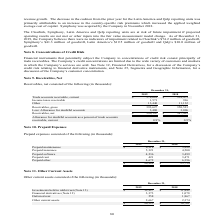According to Sykes Enterprises Incorporated's financial document, What was the amount of deferred rent in 2019? According to the financial document, 558 (in thousands). The relevant text states: "Deferred rent 558 1,867..." Also, What was the amount of Other current assets in 2018? According to the financial document, 2,374 (in thousands). The relevant text states: "Other current assets 2,667 2,374..." Also, What are the components under other current assets in the table? The document contains multiple relevant values: Investments held in rabbi trust, Financial derivatives, Deferred rent, Other current assets. From the document: "Investments held in rabbi trust (Note 13) $ 13,927 $ 11,442 Other current assets 2,667 2,374 Deferred rent 558 1,867 Financial derivatives (Note 12) 3..." Additionally, In which year was the amount of Other current assets larger? According to the financial document, 2019. The relevant text states: "2019 2018..." Also, can you calculate: What was the change in total other current assets in 2019 from 2018? Based on the calculation: 20,525-16,761, the result is 3764 (in thousands). This is based on the information: "$ 20,525 $ 16,761 $ 20,525 $ 16,761..." The key data points involved are: 16,761, 20,525. Also, can you calculate: What was the percentage change in total other current assets in 2019 from 2018? To answer this question, I need to perform calculations using the financial data. The calculation is: (20,525-16,761)/16,761, which equals 22.46 (percentage). This is based on the information: "$ 20,525 $ 16,761 $ 20,525 $ 16,761..." The key data points involved are: 16,761, 20,525. 